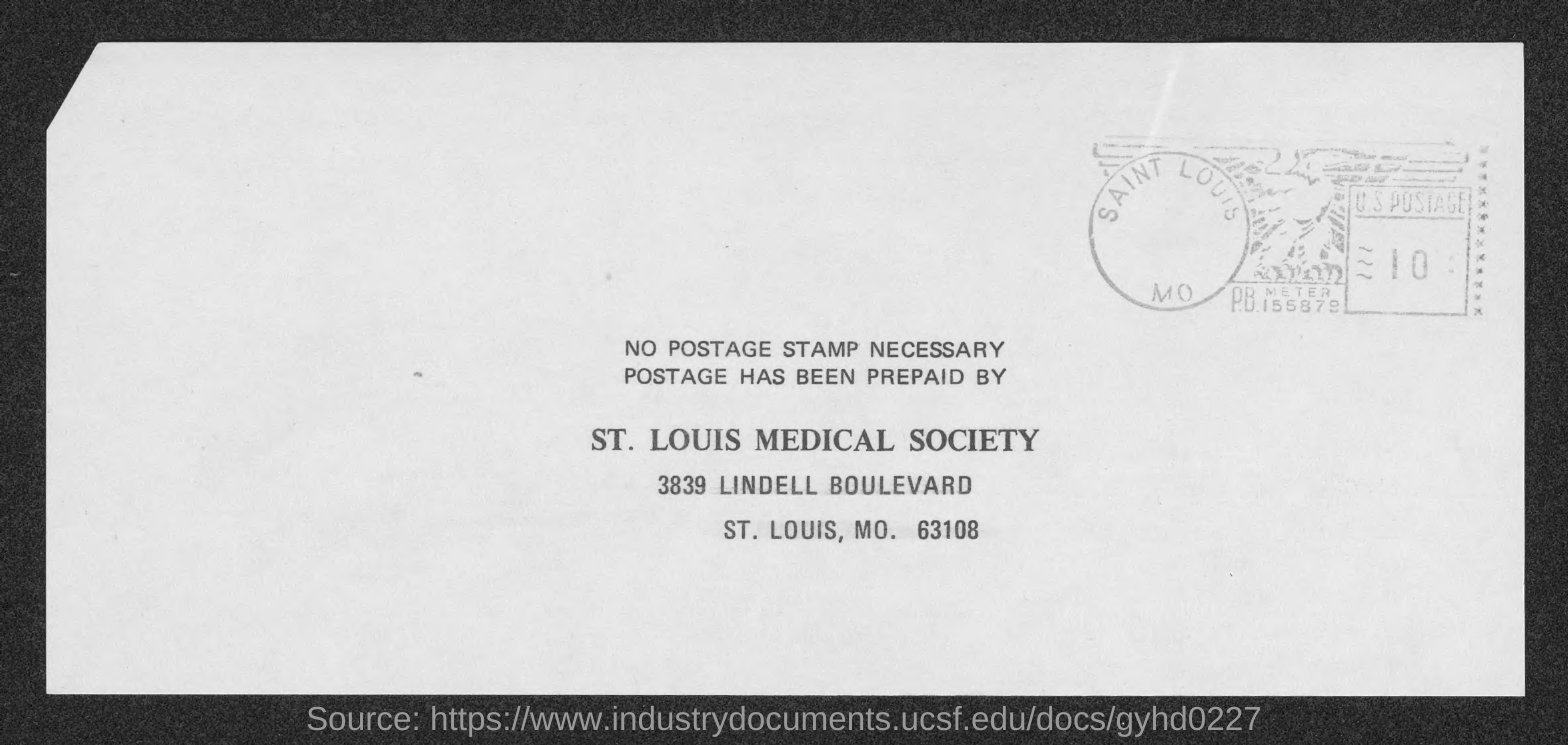Who has prepaid the postage?
Your answer should be very brief. ST. LOUIS MEDICAL SOCIETY. What is the zip code mentioned?
Provide a short and direct response. 63108. 